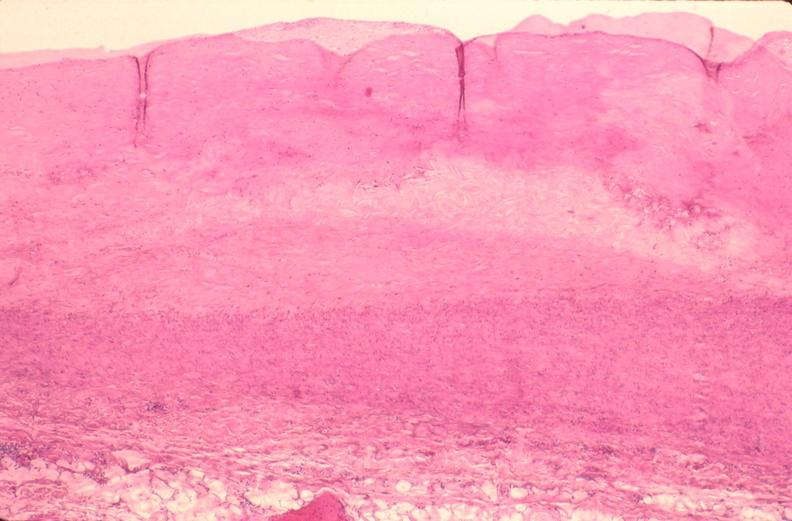s cardiovascular present?
Answer the question using a single word or phrase. Yes 